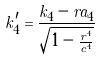<formula> <loc_0><loc_0><loc_500><loc_500>k _ { 4 } ^ { \prime } = \frac { k _ { 4 } - r a _ { 4 } } { \sqrt { 1 - \frac { r ^ { 4 } } { c ^ { 4 } } } }</formula> 